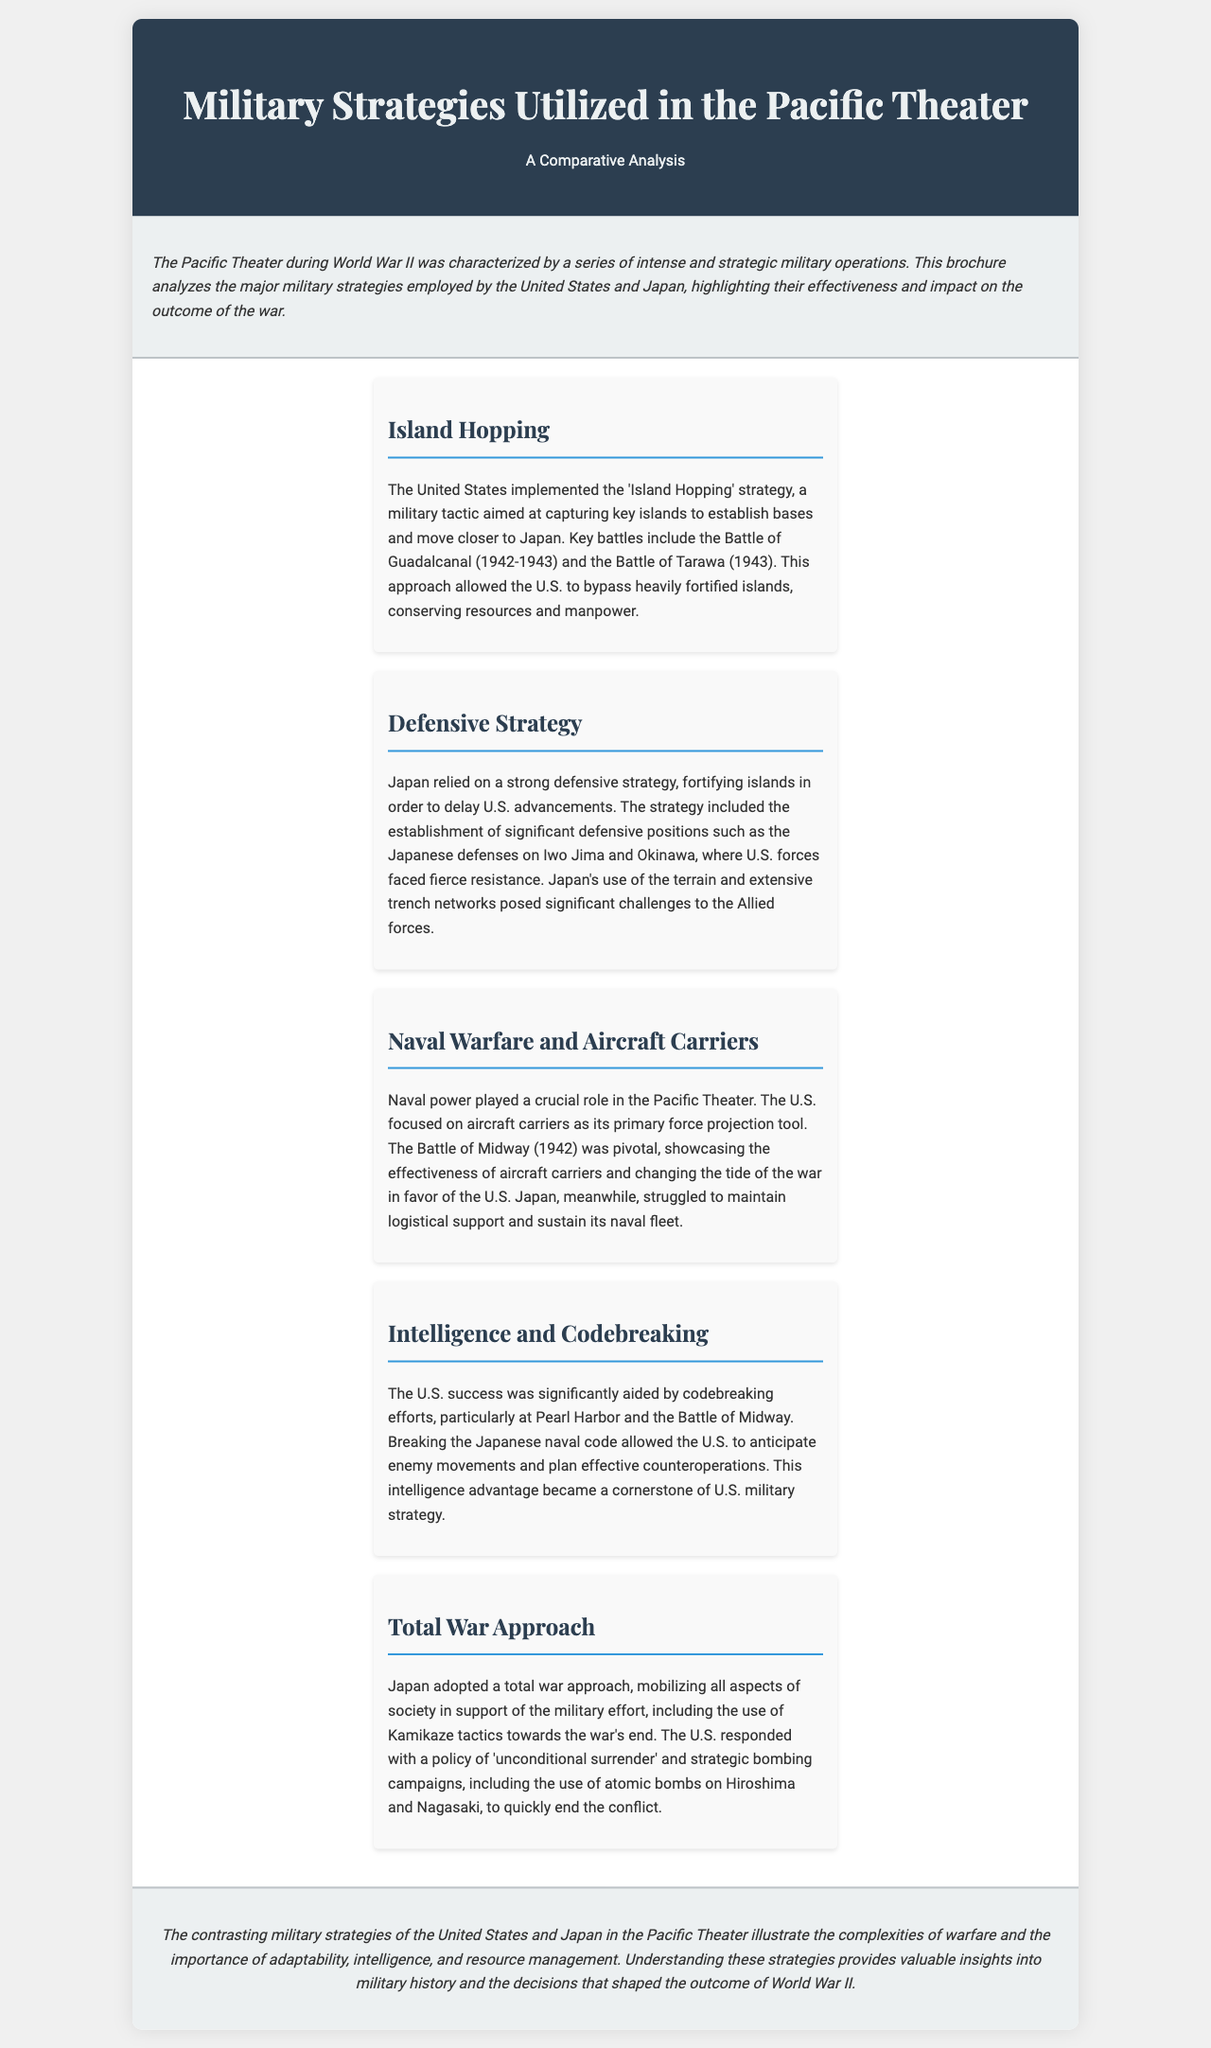What is the main strategy used by the United States in the Pacific Theater? The document states that the United States implemented the 'Island Hopping' strategy as a key military tactic.
Answer: Island Hopping Which battle is associated with the U.S. 'Island Hopping' strategy? The brochure mentions the Battle of Guadalcanal as a key battle related to the 'Island Hopping' strategy.
Answer: Battle of Guadalcanal What defensive strategy did Japan rely on? The document indicates that Japan relied on a strong defensive strategy, fortifying islands, to slow U.S. advancements.
Answer: Defensive strategy Which battle showcased the effectiveness of aircraft carriers for the U.S.? The document highlights the Battle of Midway as pivotal in demonstrating U.S. naval power with aircraft carriers.
Answer: Battle of Midway What major advantage did U.S. forces gain from intelligence efforts? The U.S. success in the Pacific Theater was significantly aided by codebreaking efforts that allowed them to anticipate enemy movements.
Answer: Codebreaking How did Japan's approach to warfare change towards the end of the war? The brochure mentions that Japan adopted a total war approach and utilized Kamikaze tactics.
Answer: Total war approach What was the U.S. response to Japan's total war approach? The document states that the U.S. responded with a policy of 'unconditional surrender' and strategic bombing campaigns.
Answer: Unconditional surrender What does the conclusion of the brochure emphasize about military strategies? The conclusion emphasizes the importance of adaptability, intelligence, and resource management in military strategies during the Pacific Theater.
Answer: Adaptability, intelligence, resource management 